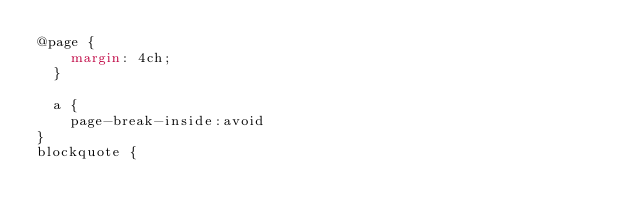<code> <loc_0><loc_0><loc_500><loc_500><_CSS_>@page {
    margin: 4ch;
  }

  a {
    page-break-inside:avoid
}
blockquote {</code> 